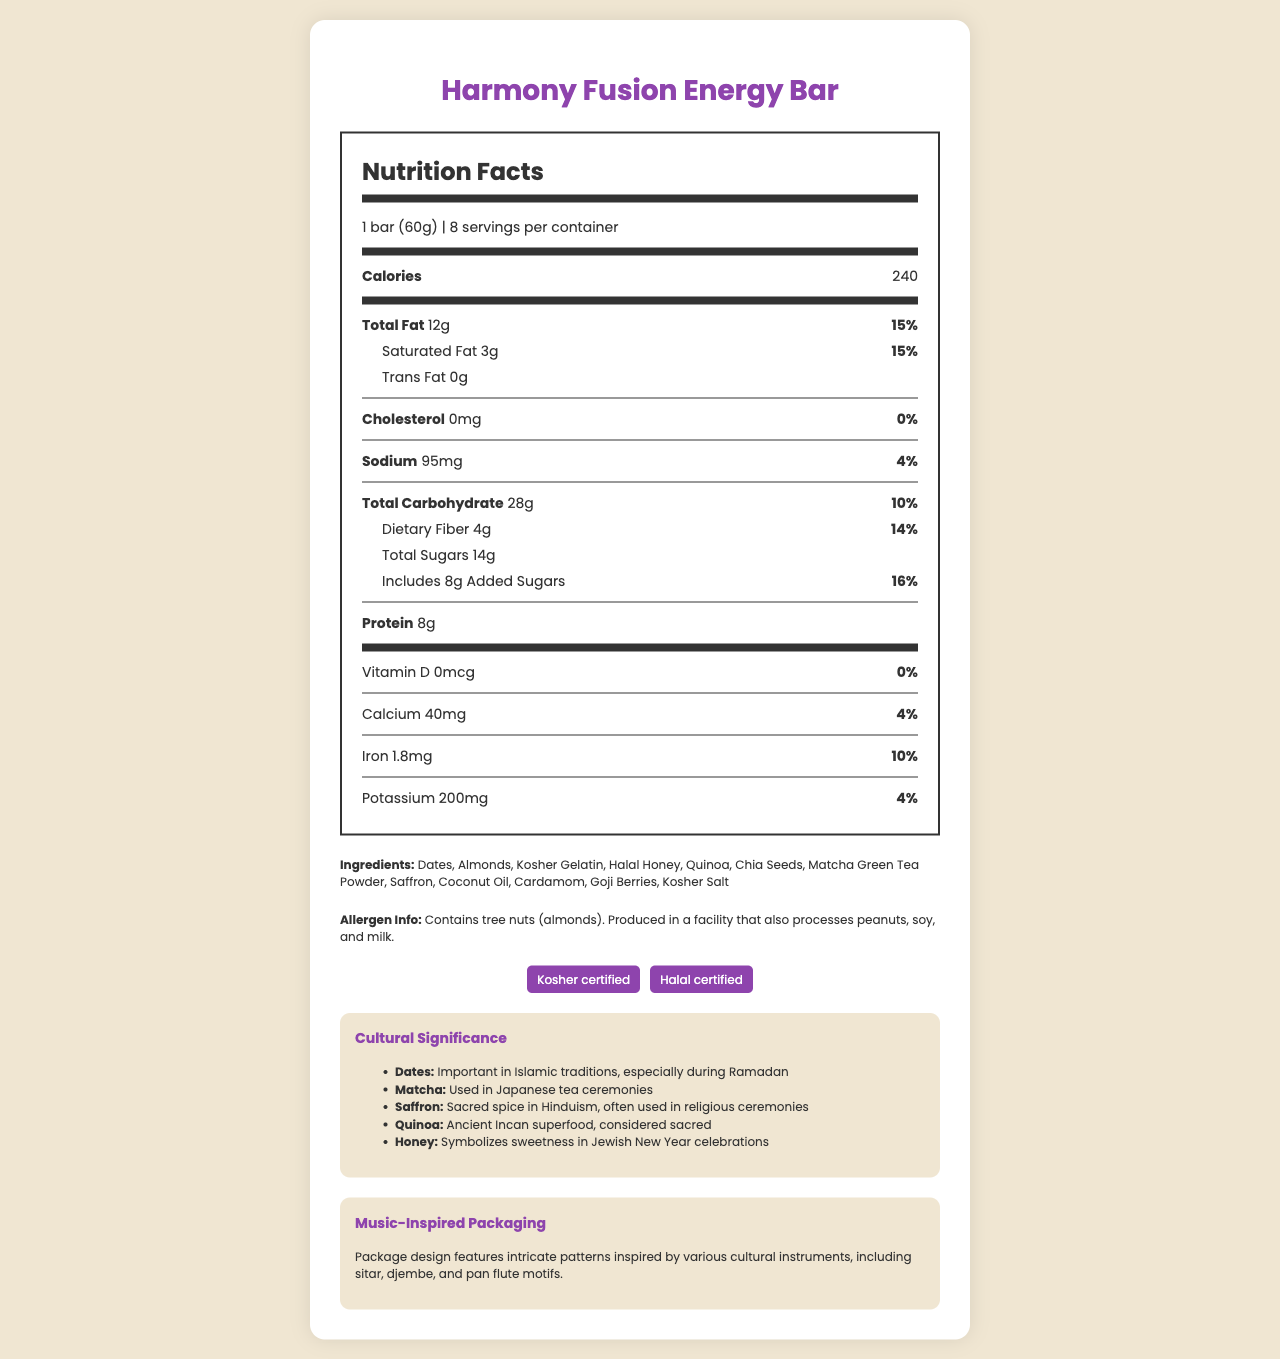What is the serving size of the Harmony Fusion Energy Bar? The serving size is clearly stated at the top of the Nutrition Facts section as 1 bar (60g).
Answer: 1 bar (60g) How many calories are in one serving? The number of calories per serving is displayed prominently under the "Calories" label.
Answer: 240 What percentage of the daily value of total fat does one bar contain? The daily value percentage for total fat is shown next to the total fat amount (12g).
Answer: 15% What ingredients are listed in the Harmony Fusion Energy Bar? The ingredients are listed in the “Ingredients” section near the bottom of the document.
Answer: Dates, Almonds, Kosher Gelatin, Halal Honey, Quinoa, Chia Seeds, Matcha Green Tea Powder, Saffron, Coconut Oil, Cardamom, Goji Berries, Kosher Salt Which religious certifications does the Harmony Fusion Energy Bar have? The religious certifications are listed under the "Certifications" section.
Answer: Kosher certified, Halal certified How much dietary fiber is in one serving of the bar? The dietary fiber content is listed under the Total Carbohydrate section.
Answer: 4g Which ingredient in the Harmony Fusion Energy Bar is significant during the Jewish New Year celebrations for its symbolism of sweetness? A. Dates B. Halal Honey C. Matcha Green Tea Powder D. Saffron According to the cultural significance section, honey symbolizes sweetness in Jewish New Year celebrations.
Answer: B. Halal Honey Which of the following nutrients does the Harmony Fusion Energy Bar not provide any of? A. Vitamin D B. Calcium C. Iron D. Potassium The amount and daily value of Vitamin D are both listed as 0 in the nutrition facts.
Answer: A. Vitamin D Does the bar contain any cholesterol? The cholesterol amount is listed as 0mg with a 0% daily value.
Answer: No Is the Harmony Fusion Energy Bar made in a facility that processes peanuts, soy, and milk? The allergen information mentions that it is produced in a facility that also processes peanuts, soy, and milk.
Answer: Yes Summarize the cultural and religious significance of some ingredients in the Harmony Fusion Energy Bar. The summary question covers the broad cultural significance of various ingredients, showcasing the multicultural aspects integrated into the bar's recipe.
Answer: The Harmony Fusion Energy Bar contains ingredients with diverse cultural and religious significances: Dates are important in Islamic traditions, especially during Ramadan; Matcha is used in Japanese tea ceremonies; Saffron is a sacred spice in Hinduism and often used in religious ceremonies; Quinoa is considered an ancient Incan superfood; Honey symbolizes sweetness in Jewish New Year celebrations. What is the sodium content in one bar? The sodium content is clearly listed under the sodium label in the Nutrition Facts section.
Answer: 95mg Can it be determined if the bar is gluten-free from the document? The document does not provide information about gluten content or any certification indicating that the product is gluten-free.
Answer: Cannot be determined 